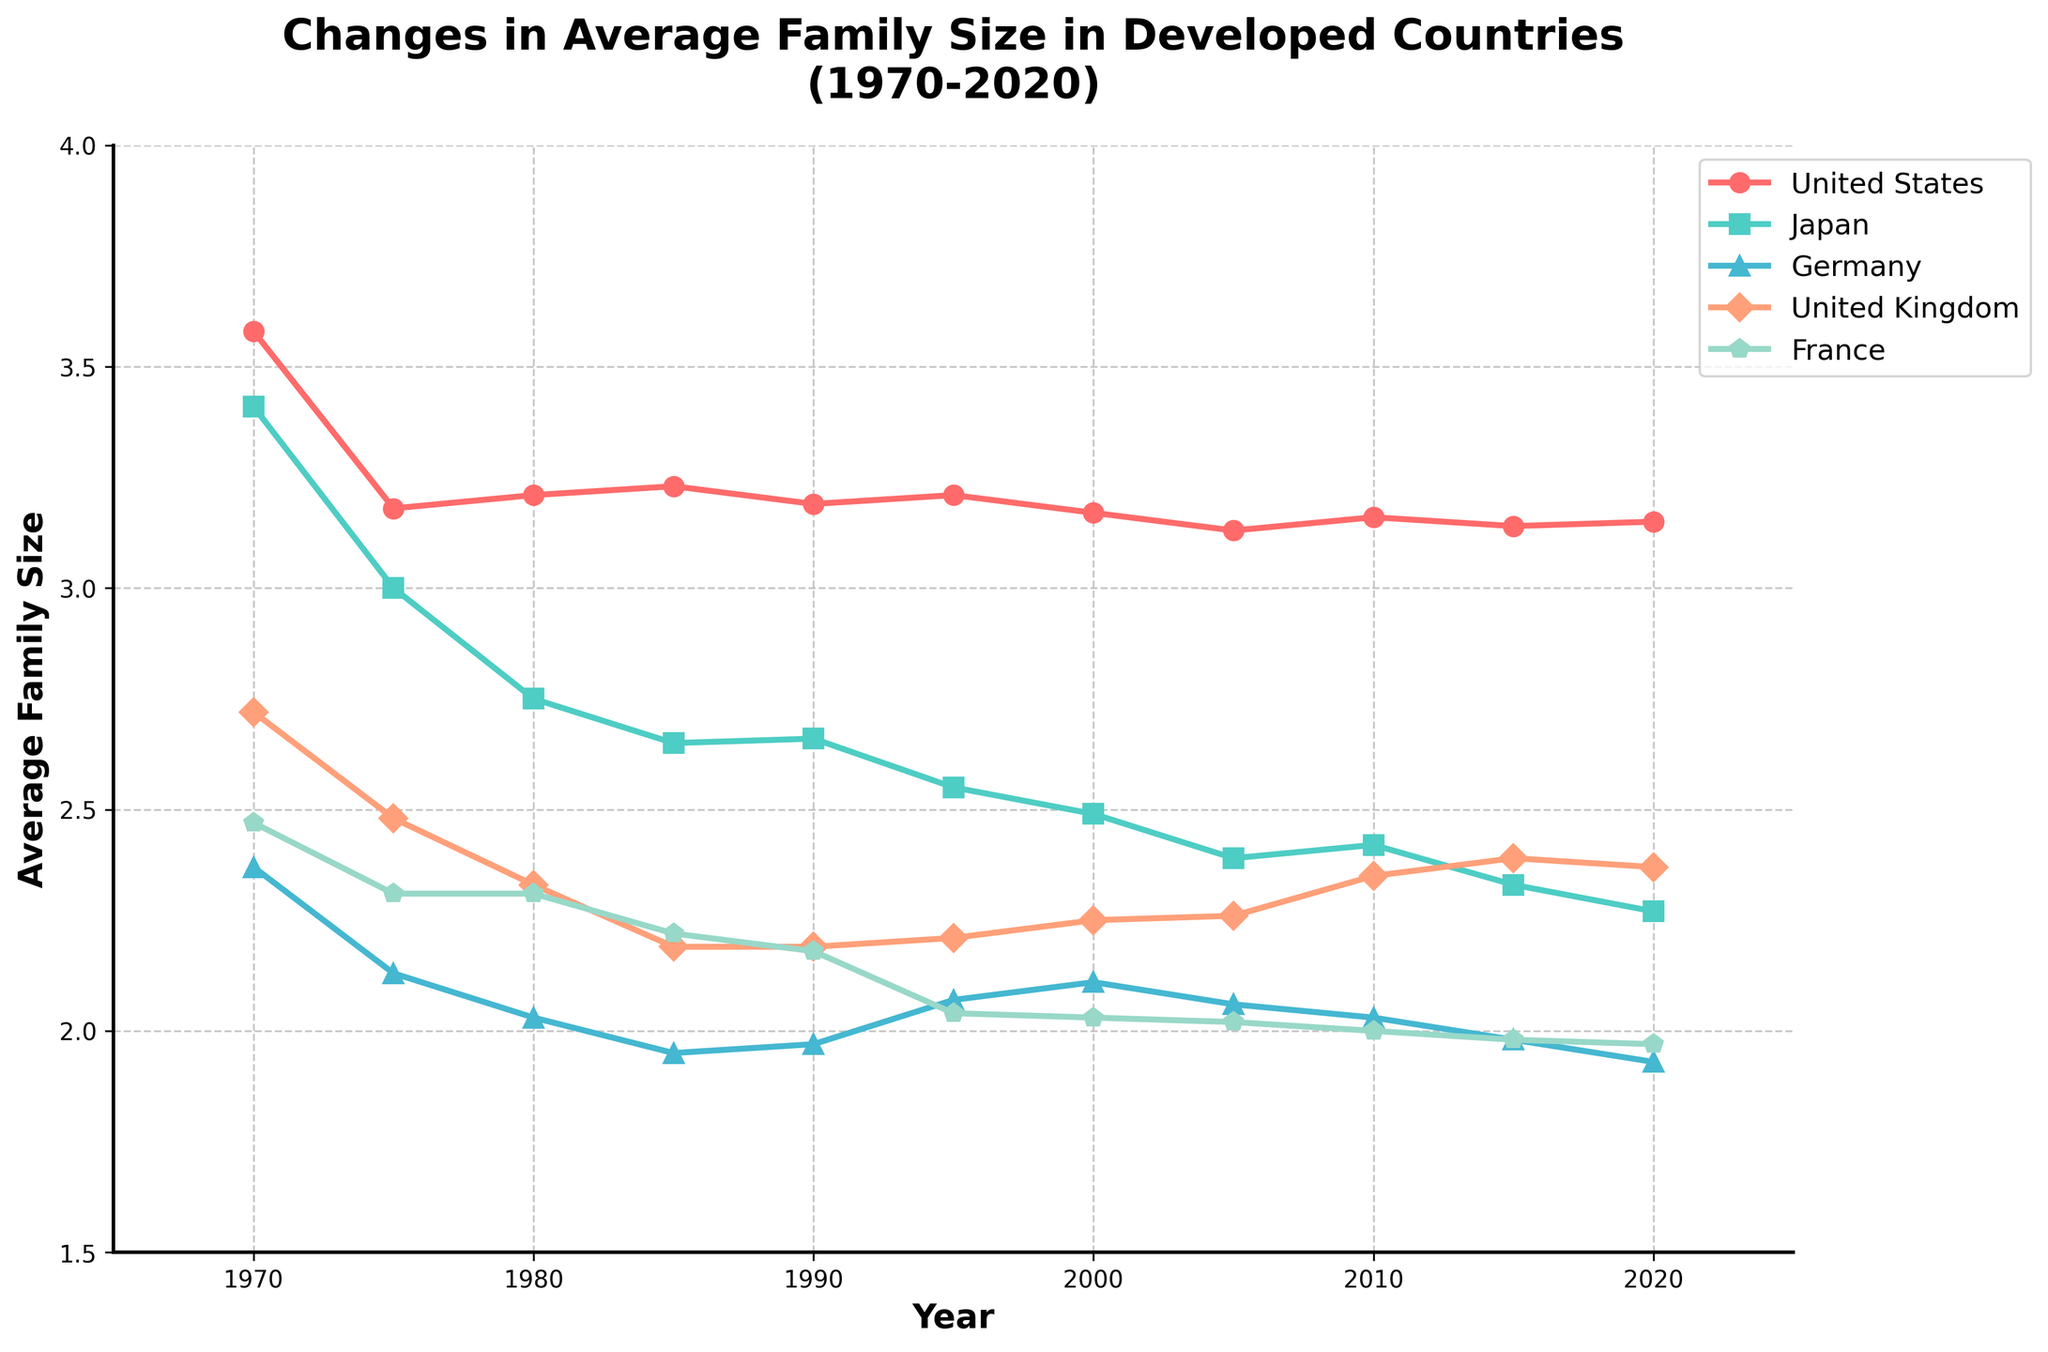What country had the largest average family size in 1970? To find this, look at the 1970 data points for all countries and compare their average family sizes. The United States has the largest value at 3.58.
Answer: United States Which country shows the smallest drop in average family size from 1970 to 2020? Calculate the amount decreased for each country from 1970 to 2020. The United States decreases from 3.58 to 3.15 (0.43), Japan from 3.41 to 2.27 (1.14), Germany from 2.37 to 1.93 (0.44), the United Kingdom from 2.72 to 2.37 (0.35), and France from 2.47 to 1.97 (0.50). The United Kingdom shows the smallest drop at 0.35.
Answer: United Kingdom What trends can be observed in the average family size in Germany over the last 50 years? Looking at the plotted points for Germany from 1970 to 2020, the size steadily decreases from 2.37 in 1970 to 1.93 in 2020.
Answer: Declining trend Which country had the largest family size in 2010, and what was it? Compare the 2010 data for all countries. The United States had the largest family size, which was 3.16.
Answer: United States, 3.16 Did any country see an increase in average family size at any point over the 50 years? Reviewing the changes in the graph for each country: the United States had minor fluctuations but no overall increase, Japan and Germany consistently declined, the United Kingdom and France also show generally declining trends. The United Kingdom shows a slight increase from 2.25 in 2000 to 2.26 in 2005 and from 2.35 in 2010 to 2.39 in 2015 but overall trends are downward.
Answer: None showed an overall increase How did the average family size in France change from 1980 to 2005? Compare the family size data points for France in 1980 (2.31) and 2005 (2.02). The average size decreased by 0.29.
Answer: Decreased by 0.29 What is the range of average family sizes in each country for the years shown? Determine the range (max value - min value) for each country's family size across all years:
- United States: 3.58 - 3.13 = 0.45
- Japan: 3.41 - 2.27 = 1.14
- Germany: 2.37 - 1.93 = 0.44
- United Kingdom: 2.72 - 2.19 = 0.53
- France: 2.47 - 1.97 = 0.50
Answer: US: 0.45, Japan: 1.14, Germany: 0.44, UK: 0.53, France: 0.50 Which years saw the most significant change in average family size for the United States? Review the changes year-over-year for the United States. The most significant changes occur from 1970 to 1975 (3.58 to 3.18, a decrease of 0.40).
Answer: 1970 to 1975 What was the average family size for Japan in 1975, and how does this compare to the average family size for Germany in the same year? The average family size in Japan in 1975 was 3.00, while in Germany, it was 2.13. Japan's average family size was larger by 0.87.
Answer: Japan: 3.00, Germany: 2.13, Difference: 0.87 What color represents the United Kingdom on the chart, and what visual trend does it show? The United Kingdom is represented by the color orange. The visual trend shows a general decrease in average family size from 2.72 in 1970 to 2.37 in 2020, with minor fluctuations.
Answer: Orange, decreasing trend 